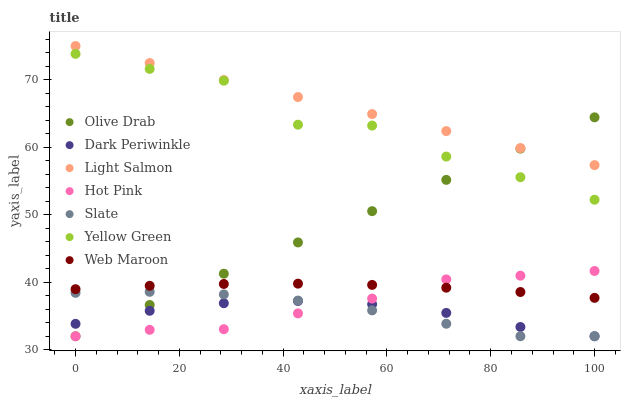Does Dark Periwinkle have the minimum area under the curve?
Answer yes or no. Yes. Does Light Salmon have the maximum area under the curve?
Answer yes or no. Yes. Does Yellow Green have the minimum area under the curve?
Answer yes or no. No. Does Yellow Green have the maximum area under the curve?
Answer yes or no. No. Is Olive Drab the smoothest?
Answer yes or no. Yes. Is Yellow Green the roughest?
Answer yes or no. Yes. Is Slate the smoothest?
Answer yes or no. No. Is Slate the roughest?
Answer yes or no. No. Does Slate have the lowest value?
Answer yes or no. Yes. Does Yellow Green have the lowest value?
Answer yes or no. No. Does Light Salmon have the highest value?
Answer yes or no. Yes. Does Yellow Green have the highest value?
Answer yes or no. No. Is Slate less than Web Maroon?
Answer yes or no. Yes. Is Light Salmon greater than Web Maroon?
Answer yes or no. Yes. Does Light Salmon intersect Olive Drab?
Answer yes or no. Yes. Is Light Salmon less than Olive Drab?
Answer yes or no. No. Is Light Salmon greater than Olive Drab?
Answer yes or no. No. Does Slate intersect Web Maroon?
Answer yes or no. No. 